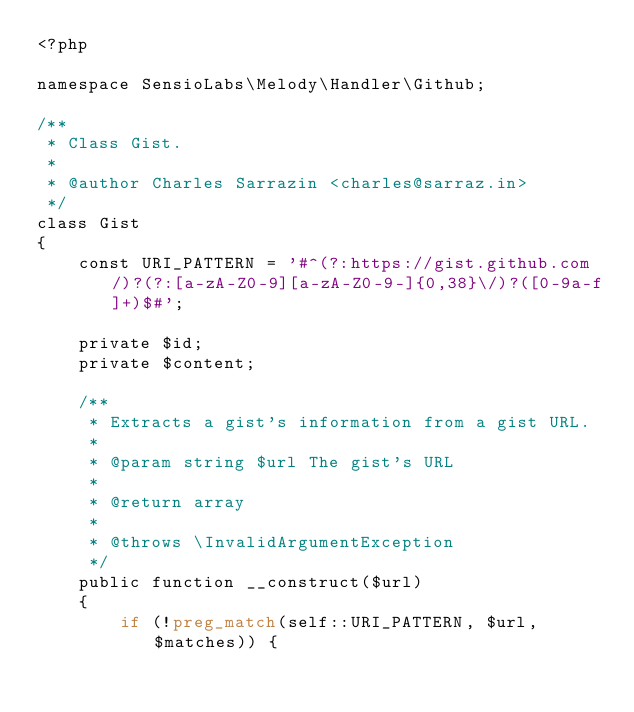<code> <loc_0><loc_0><loc_500><loc_500><_PHP_><?php

namespace SensioLabs\Melody\Handler\Github;

/**
 * Class Gist.
 *
 * @author Charles Sarrazin <charles@sarraz.in>
 */
class Gist
{
    const URI_PATTERN = '#^(?:https://gist.github.com/)?(?:[a-zA-Z0-9][a-zA-Z0-9-]{0,38}\/)?([0-9a-f]+)$#';

    private $id;
    private $content;

    /**
     * Extracts a gist's information from a gist URL.
     *
     * @param string $url The gist's URL
     *
     * @return array
     *
     * @throws \InvalidArgumentException
     */
    public function __construct($url)
    {
        if (!preg_match(self::URI_PATTERN, $url, $matches)) {</code> 